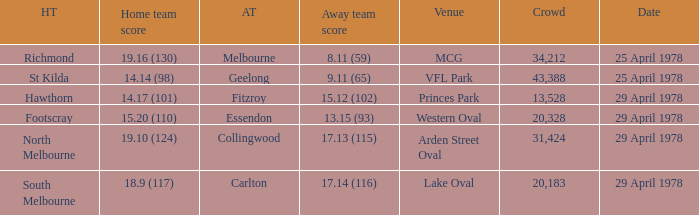Who was the home team at MCG? Richmond. 